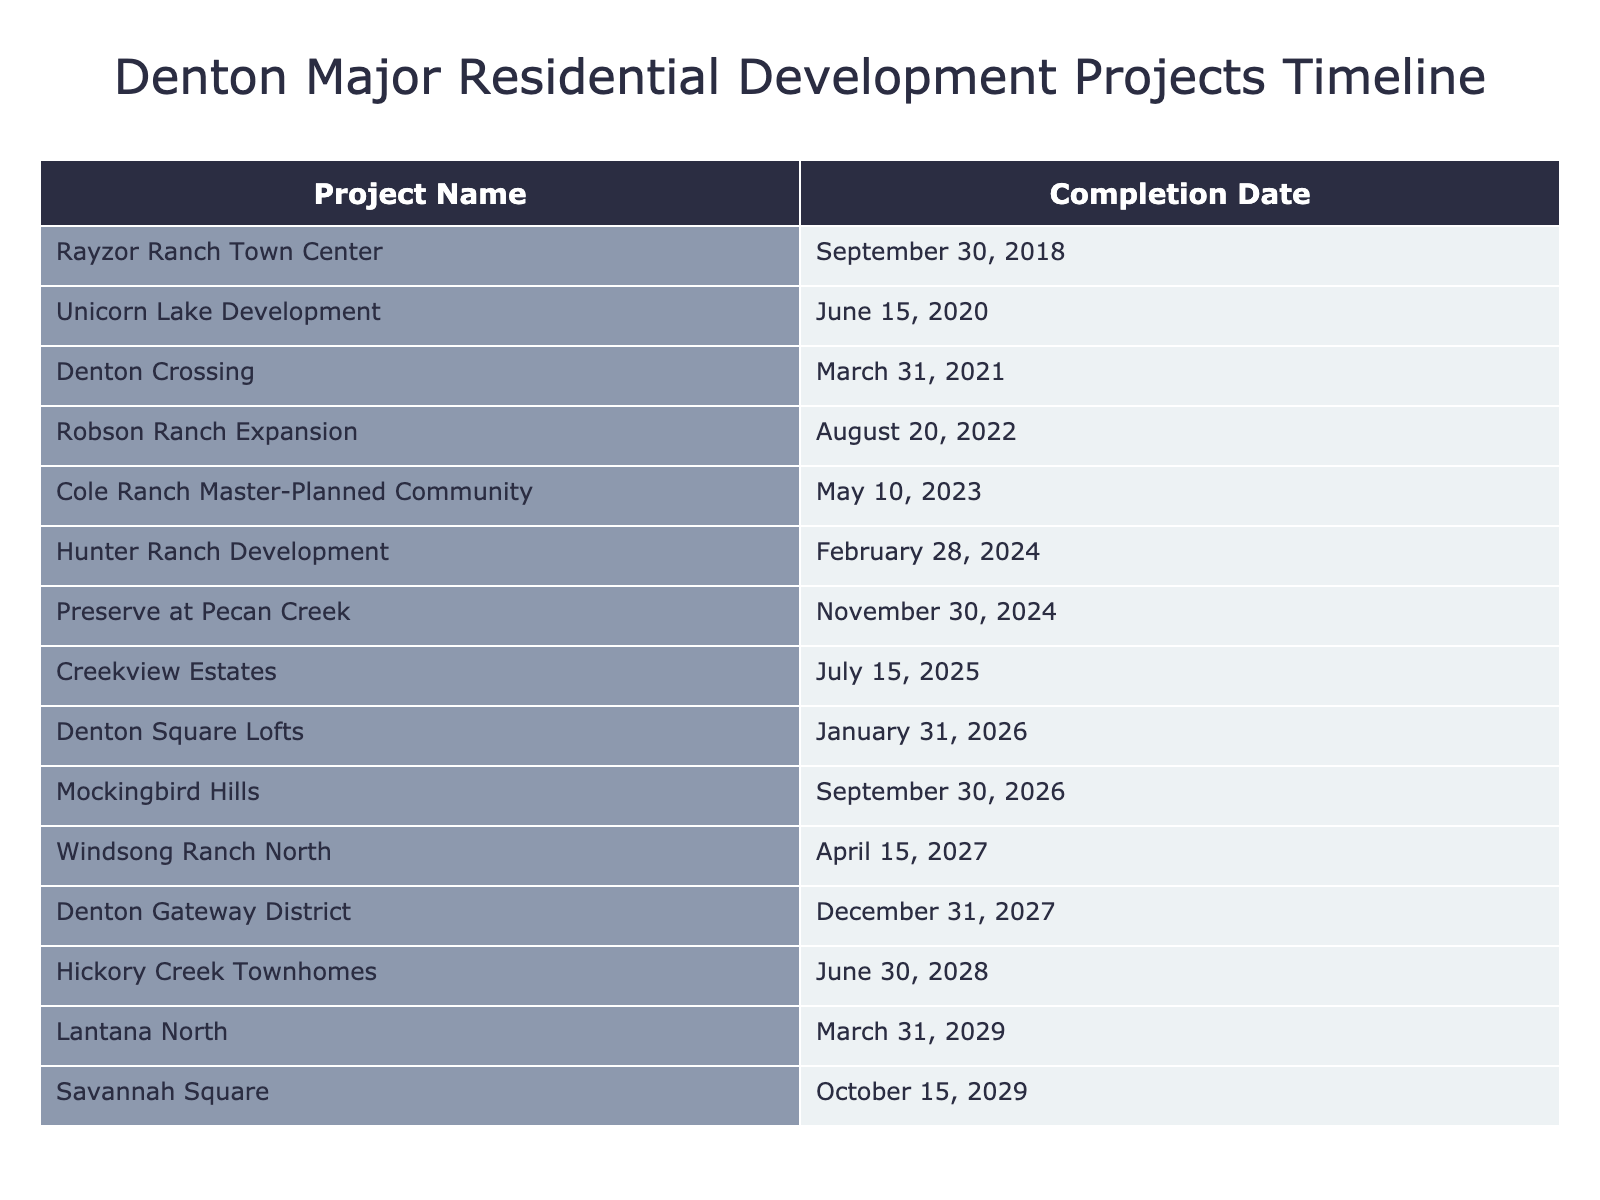What is the completion date for Rayzor Ranch Town Center? The table shows the completion date for Rayzor Ranch Town Center listed under the "Completion Date" column, which is September 30, 2018.
Answer: September 30, 2018 How many projects are scheduled to be completed in 2024? By counting the entries in the table for the year 2024, I find that there are three projects: Hunter Ranch Development, Preserve at Pecan Creek, and the total is 3.
Answer: 3 Is the Unicorn Lake Development completed before Robson Ranch Expansion? To determine this, I check the completion dates. Unicorn Lake Development was completed on June 15, 2020, while Robson Ranch Expansion was completed on August 20, 2022. Since 2020 comes before 2022, the statement is true.
Answer: Yes What is the latest project completion date listed in the table? I review the "Completion Date" column and find that the latest completion date is December 31, 2027, for Denton Gateway District.
Answer: December 31, 2027 How many years are between the completion of Cole Ranch Master-Planned Community and Hickory Creek Townhomes? Cole Ranch Master-Planned Community was completed on May 10, 2023, and Hickory Creek Townhomes is set for completion on June 30, 2028. The difference between these dates is 5 years, about 1 month.
Answer: 5 years What is the median completion date for the projects? To find the median, I would list all completion dates in order: September 30, 2018; June 15, 2020; March 31, 2021; August 20, 2022; May 10, 2023; February 28, 2024; November 30, 2024; January 31, 2026; September 30, 2026; April 15, 2027; December 31, 2027; June 30, 2028; March 31, 2029; October 15, 2029. There are 14 dates, so I take the average of the 7th and 8th dates, which are February 28, 2024, and January 31, 2026, giving a median date around July 2025.
Answer: July 2025 Does Denton Square Lofts complete its project before Mockingbird Hills? Looking at the table, Denton Square Lofts is completed on January 31, 2026, and Mockingbird Hills on September 30, 2026. Since January 31 comes before September 30, the answer is yes.
Answer: Yes What is the total number of projects listed in the table? I can count the number of entries in the table, which shows a total of 14 projects.
Answer: 14 